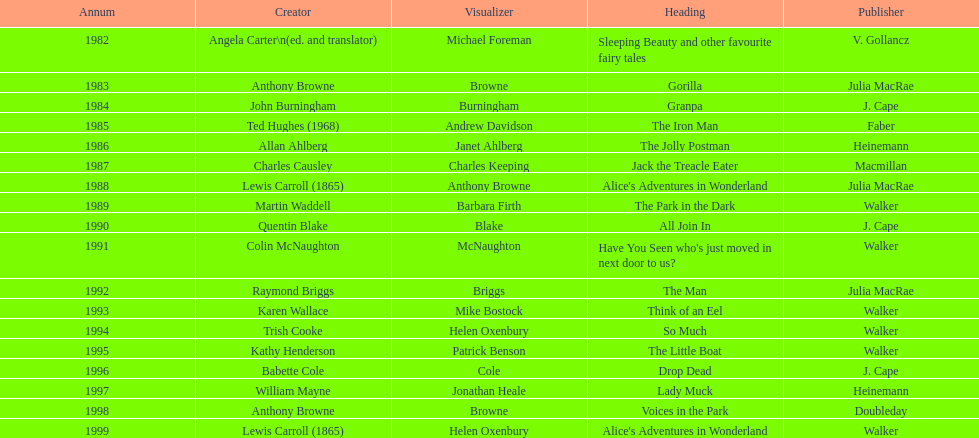What is the only title listed for 1999? Alice's Adventures in Wonderland. 